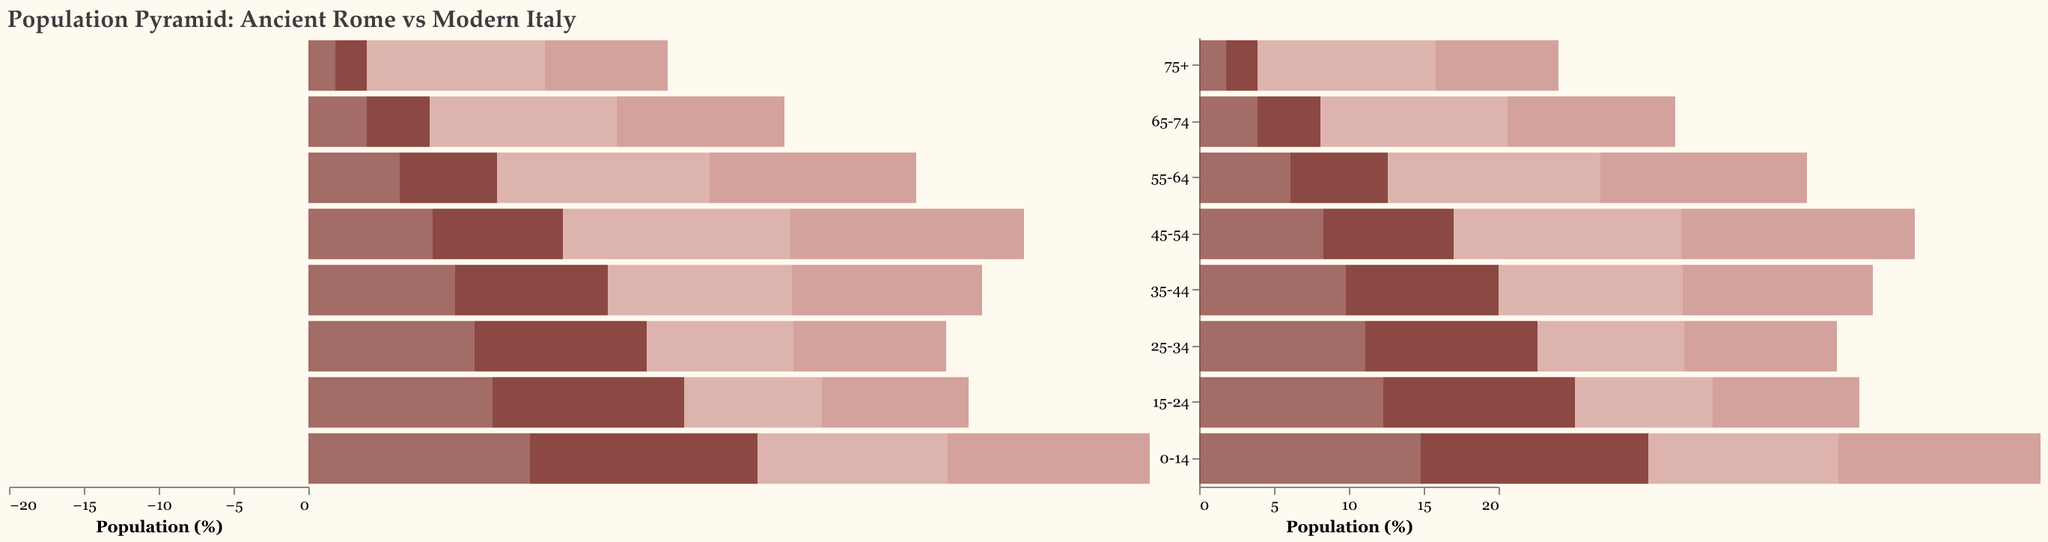What is the title of the figure? The title of the figure is prominently displayed at the top, summarizing the content of the visual representation.
Answer: Population Pyramid: Ancient Rome vs Modern Italy Which era has the larger percentage of males in the age group 45-54? To determine this, compare the length of the bars representing Ancient Rome Males and Modern Italy Males in the age group 45-54. The bar for Modern Italy Males extends further to the left than the bar for Ancient Rome Males.
Answer: Modern Italy How does the population distribution of females in the 75+ age group in Ancient Rome compare to Modern Italy? By looking at the bars for the 75+ age group for females in both eras, the bar for Modern Italy Females is longer than that for Ancient Rome Females, indicating that a higher percentage of females in this age group is in Modern Italy.
Answer: Modern Italy has a higher percentage In which age group is the difference between males and females the smallest in Ancient Rome? Compare the length differences between male and female bars within each age group for Ancient Rome. The smallest difference in bar lengths is in the age group 35-44.
Answer: 35-44 Which age group has the highest percentage of females in Modern Italy? Find the bar reaching the furthest to the right for Modern Italy Females. The greatest percentage of females is seen in the age group 45-54.
Answer: 45-54 What is the percentage difference between males and females in the age group 0-14 for Ancient Rome? The percentage for Ancient Rome Males is -15.2% and for Ancient Rome Females is 14.8%. Calculate the absolute difference:
Answer: 0.4 Which gender has a more evenly distributed population across age groups in Modern Italy? Examine the bars representing different age groups for both males and females in Modern Italy. Males tend to have similar bar lengths across various age groups compared to females, who have more pronounced differences.
Answer: Males How does the population of males in the age group 25-34 compare between Ancient Rome and Modern Italy? Compare the lengths of the two bars for males in the 25-34 age group. The bar for Ancient Rome Males is longer than that for Modern Italy Males, implying a higher percentage in Ancient Rome.
Answer: Ancient Rome 